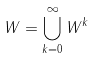<formula> <loc_0><loc_0><loc_500><loc_500>W = \bigcup _ { k = 0 } ^ { \infty } W ^ { k }</formula> 